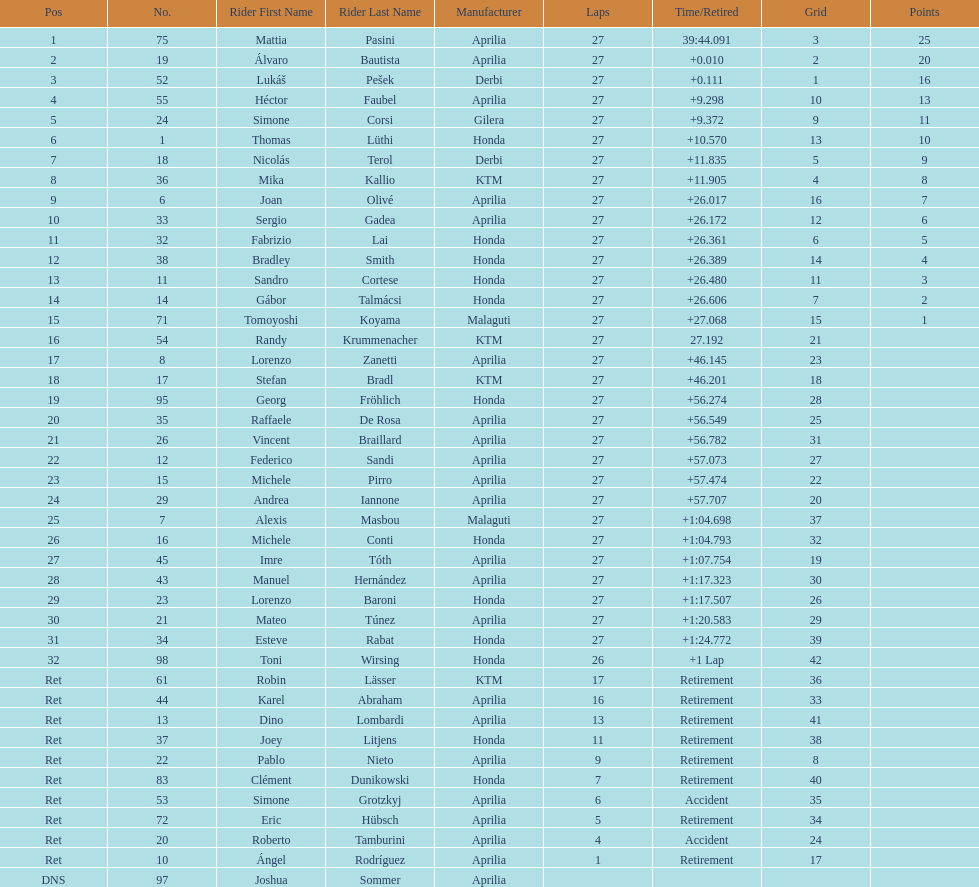Which rider came in first with 25 points? Mattia Pasini. 